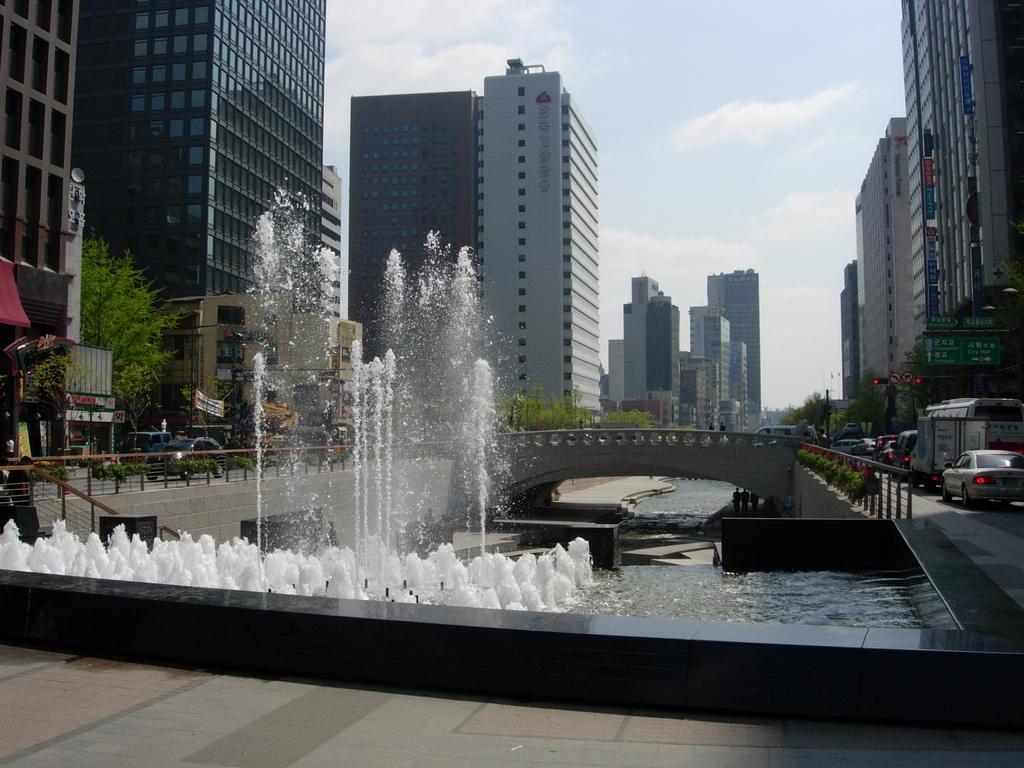Please provide a concise description of this image. In this image there is a ground at bottom of this image and there is a fountain as we can see in middle of this image and there is a bridge at right side of this image and there are some buildings in the background. There are some trees in middle of this image and there are some vehicles at left side of this image and right side of this image as well. there is a sky at top of this image. 